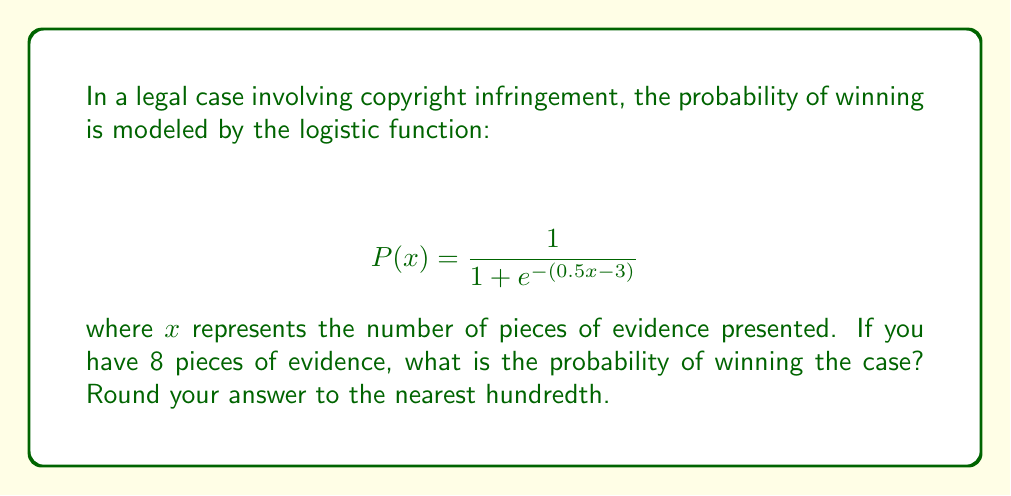Give your solution to this math problem. To solve this problem, we need to follow these steps:

1. Identify the given information:
   - The logistic function is $P(x) = \frac{1}{1 + e^{-(0.5x - 3)}}$
   - We have $x = 8$ pieces of evidence

2. Substitute $x = 8$ into the function:
   $P(8) = \frac{1}{1 + e^{-(0.5(8) - 3)}}$

3. Simplify the expression inside the exponent:
   $P(8) = \frac{1}{1 + e^{-(4 - 3)}} = \frac{1}{1 + e^{-1}}$

4. Calculate $e^{-1}$:
   $e^{-1} \approx 0.3679$

5. Substitute this value and calculate the probability:
   $P(8) = \frac{1}{1 + 0.3679} = \frac{1}{1.3679} \approx 0.7310$

6. Round to the nearest hundredth:
   $0.7310 \approx 0.73$

Therefore, the probability of winning the case with 8 pieces of evidence is approximately 0.73 or 73%.
Answer: $0.73$ 